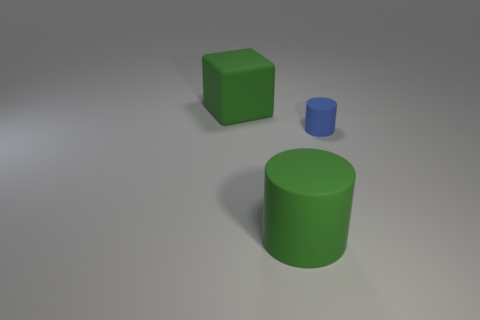There is a large object that is the same color as the block; what material is it?
Your answer should be very brief. Rubber. What number of things are rubber cylinders or big matte things that are to the right of the large green block?
Your answer should be very brief. 2. What number of metal blocks are there?
Offer a very short reply. 0. Are there any other matte things that have the same size as the blue object?
Provide a short and direct response. No. Are there fewer large matte cubes that are behind the blue object than green rubber objects?
Give a very brief answer. Yes. Do the green matte cylinder and the blue rubber cylinder have the same size?
Your answer should be very brief. No. The blue cylinder that is the same material as the big green cylinder is what size?
Provide a short and direct response. Small. How many objects have the same color as the large matte cylinder?
Provide a succinct answer. 1. Are there fewer large matte cubes in front of the tiny blue cylinder than blocks that are in front of the big matte cube?
Provide a succinct answer. No. Does the green object that is behind the large rubber cylinder have the same shape as the tiny blue thing?
Make the answer very short. No. 